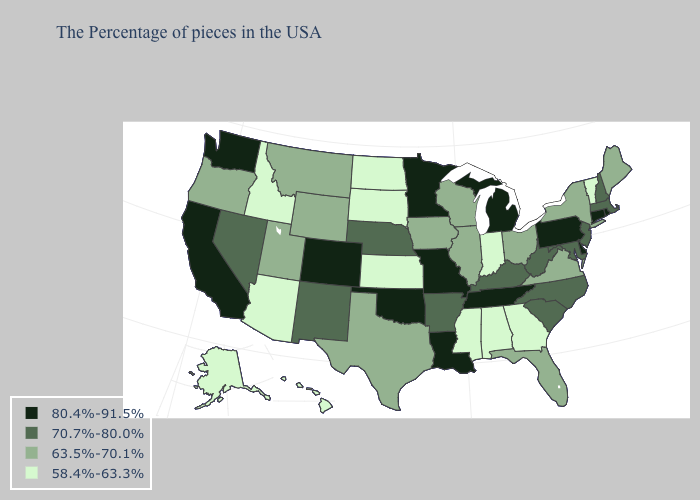What is the value of Tennessee?
Concise answer only. 80.4%-91.5%. Which states have the lowest value in the USA?
Give a very brief answer. Vermont, Georgia, Indiana, Alabama, Mississippi, Kansas, South Dakota, North Dakota, Arizona, Idaho, Alaska, Hawaii. What is the lowest value in states that border Washington?
Quick response, please. 58.4%-63.3%. Name the states that have a value in the range 70.7%-80.0%?
Quick response, please. Massachusetts, New Hampshire, New Jersey, Maryland, North Carolina, South Carolina, West Virginia, Kentucky, Arkansas, Nebraska, New Mexico, Nevada. What is the value of South Dakota?
Concise answer only. 58.4%-63.3%. Which states have the lowest value in the USA?
Short answer required. Vermont, Georgia, Indiana, Alabama, Mississippi, Kansas, South Dakota, North Dakota, Arizona, Idaho, Alaska, Hawaii. Name the states that have a value in the range 58.4%-63.3%?
Answer briefly. Vermont, Georgia, Indiana, Alabama, Mississippi, Kansas, South Dakota, North Dakota, Arizona, Idaho, Alaska, Hawaii. Does Pennsylvania have the lowest value in the Northeast?
Answer briefly. No. Among the states that border Arizona , does Utah have the lowest value?
Answer briefly. Yes. Among the states that border Alabama , does Tennessee have the highest value?
Give a very brief answer. Yes. What is the value of Delaware?
Be succinct. 80.4%-91.5%. What is the value of Ohio?
Be succinct. 63.5%-70.1%. Among the states that border Kentucky , does Indiana have the lowest value?
Short answer required. Yes. Among the states that border Indiana , which have the lowest value?
Give a very brief answer. Ohio, Illinois. What is the lowest value in states that border Missouri?
Short answer required. 58.4%-63.3%. 